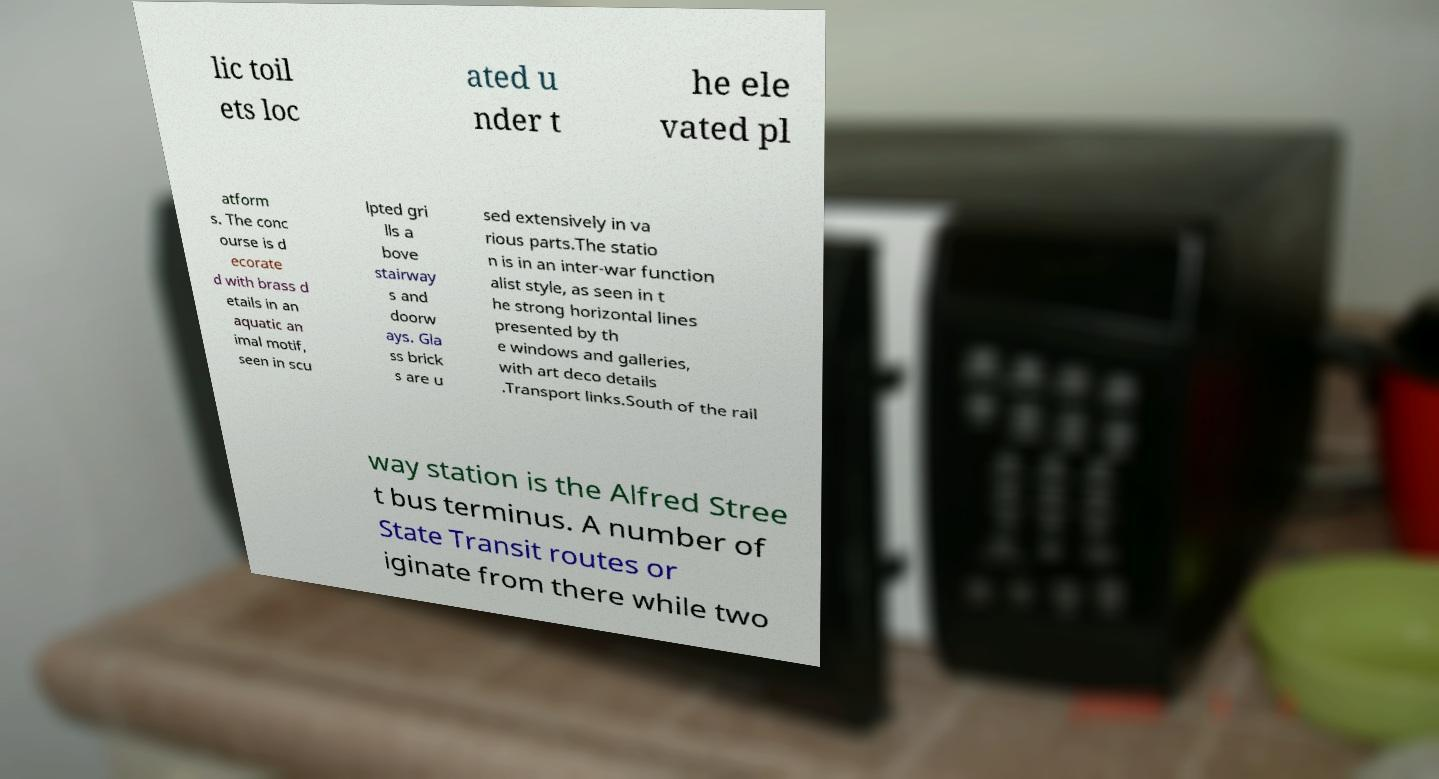What messages or text are displayed in this image? I need them in a readable, typed format. lic toil ets loc ated u nder t he ele vated pl atform s. The conc ourse is d ecorate d with brass d etails in an aquatic an imal motif, seen in scu lpted gri lls a bove stairway s and doorw ays. Gla ss brick s are u sed extensively in va rious parts.The statio n is in an inter-war function alist style, as seen in t he strong horizontal lines presented by th e windows and galleries, with art deco details .Transport links.South of the rail way station is the Alfred Stree t bus terminus. A number of State Transit routes or iginate from there while two 